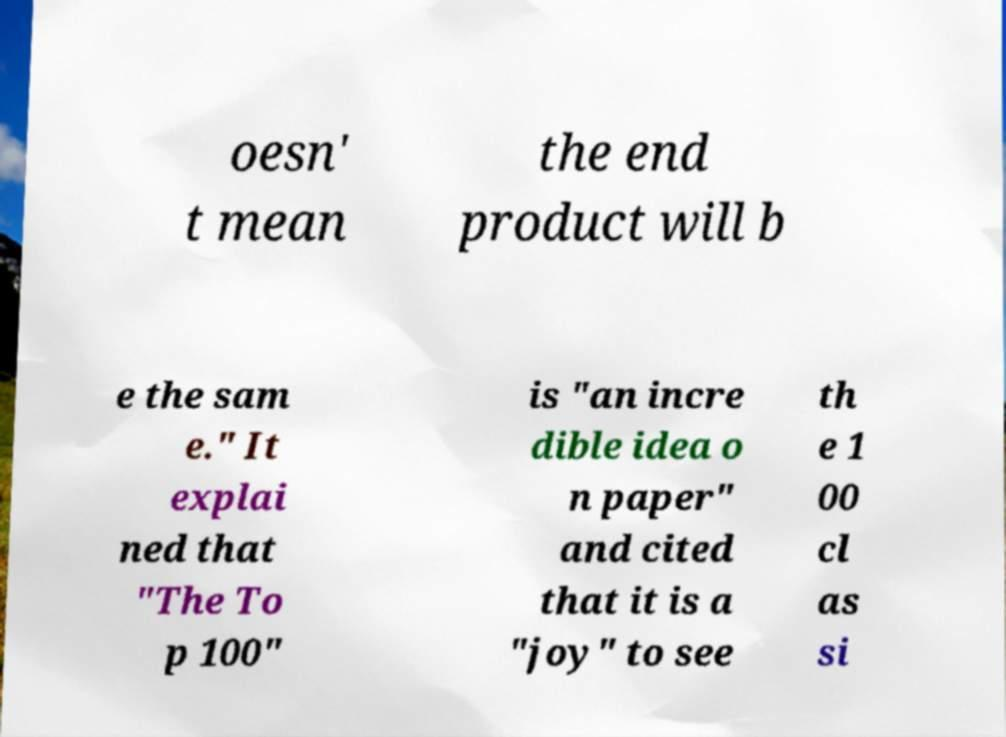Please read and relay the text visible in this image. What does it say? oesn' t mean the end product will b e the sam e." It explai ned that "The To p 100" is "an incre dible idea o n paper" and cited that it is a "joy" to see th e 1 00 cl as si 